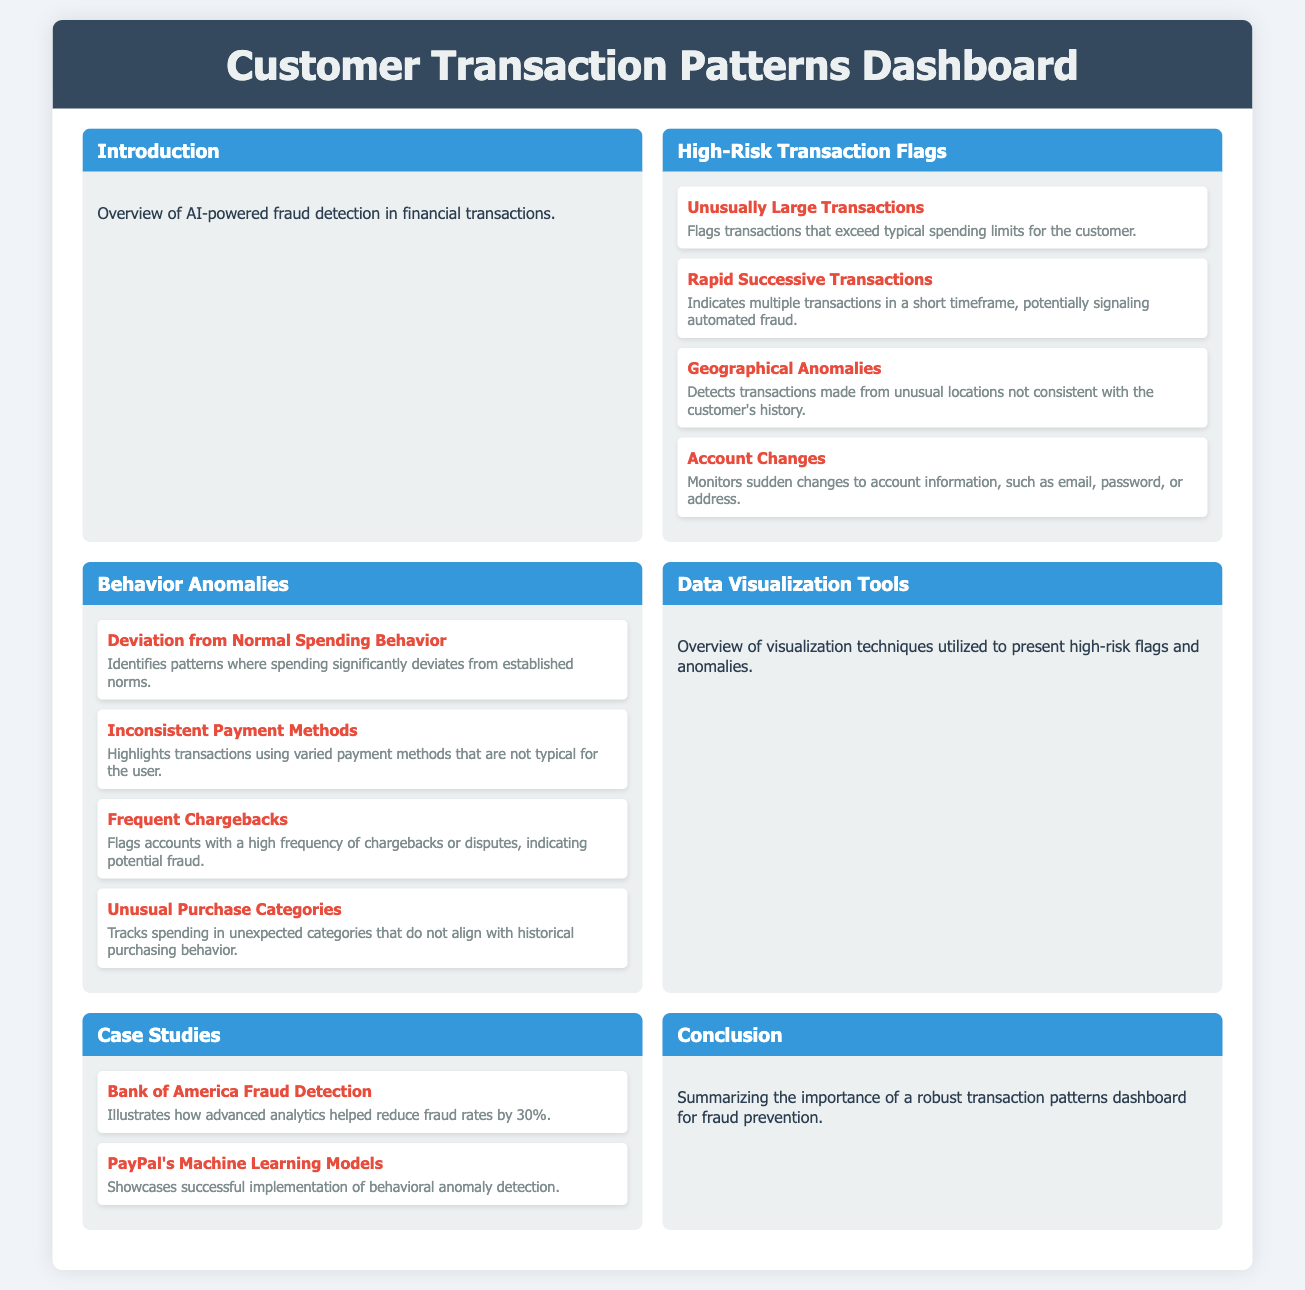What is the title of the dashboard? The title of the dashboard is mentioned at the top of the document.
Answer: Customer Transaction Patterns Dashboard How many high-risk transaction flags are listed? The document lists four high-risk transaction flags in the respective section.
Answer: 4 What behavior anomaly indicates inconsistent payment methods? The specific anomaly is mentioned among the listed behavior anomalies.
Answer: Inconsistent Payment Methods What case study showcases Bank of America's fraud detection? The case study specifically mentions the effectiveness of Bank of America's approach.
Answer: Bank of America Fraud Detection What color is used for the section headers? The color used for the section headers is specified in the document styles.
Answer: Blue Which high-risk transaction flag relates to geographical issues? The relevant flag is stated under the high-risk transaction flags section.
Answer: Geographical Anomalies What is the subtitle of the 'Data Visualization Tools' section? The document contains a description under the section header that acts as a subtitle.
Answer: Overview of visualization techniques utilized to present high-risk flags and anomalies What is the main purpose of the dashboard as stated in the conclusion? The main purpose is described briefly at the end of the document under the conclusion section.
Answer: Fraud prevention 